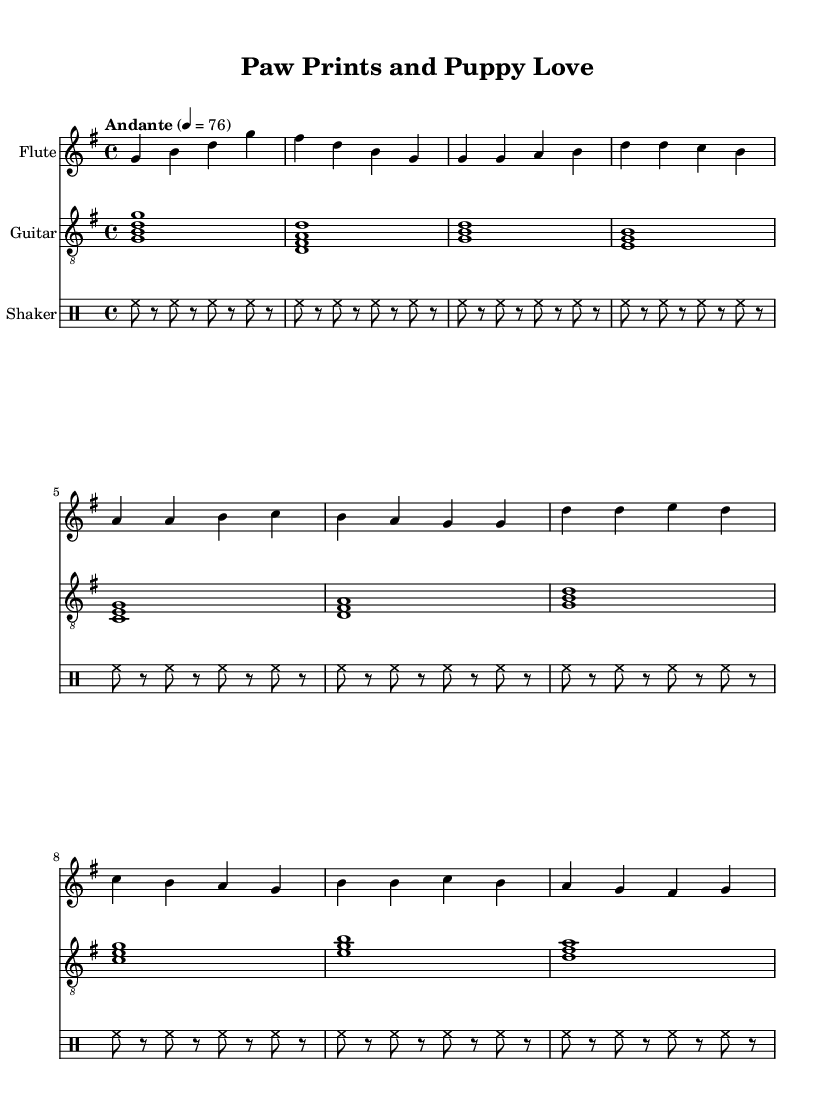What is the key signature of this music? The key signature is G major, indicated by one sharp (F#).
Answer: G major What is the time signature of this piece? The time signature is 4/4, which means there are four beats in each measure and a quarter note gets one beat.
Answer: 4/4 What is the tempo marking of the piece? The tempo marking is "Andante" with a metronome mark of 76 beats per minute.
Answer: Andante How many measures are in the flute part? The flute part has 10 measures in total, counting both the intro, verse, and chorus sections.
Answer: 10 Which instruments are featured in this score? The instruments featured are Flute, Guitar, and Shaker, which are listed at the beginning of each staff.
Answer: Flute, Guitar, Shaker How many times is the rhythmic pattern of the shaker repeated? The rhythmic pattern of the shaker is repeated 10 times. This repetition indicates consistency in the percussion throughout the piece.
Answer: 10 times What is the first note played by the flute? The first note played by the flute is G, which appears at the start of the intro section.
Answer: G 